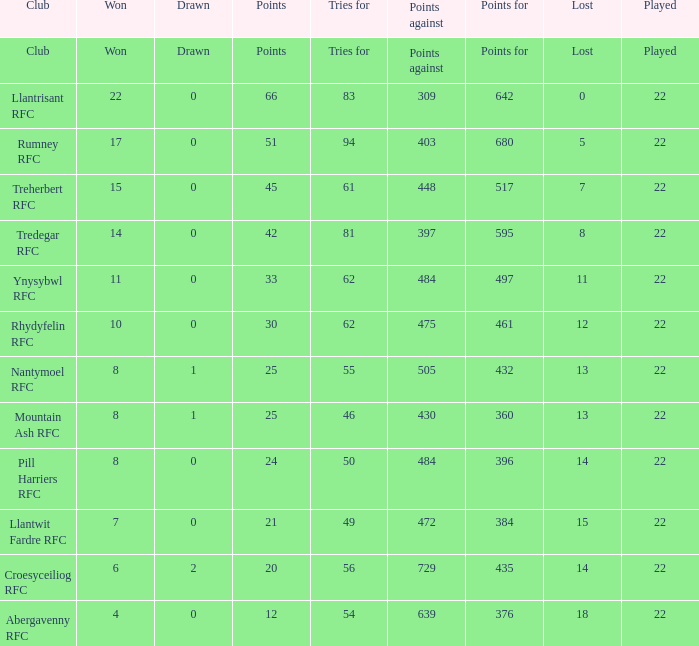Could you parse the entire table as a dict? {'header': ['Club', 'Won', 'Drawn', 'Points', 'Tries for', 'Points against', 'Points for', 'Lost', 'Played'], 'rows': [['Club', 'Won', 'Drawn', 'Points', 'Tries for', 'Points against', 'Points for', 'Lost', 'Played'], ['Llantrisant RFC', '22', '0', '66', '83', '309', '642', '0', '22'], ['Rumney RFC', '17', '0', '51', '94', '403', '680', '5', '22'], ['Treherbert RFC', '15', '0', '45', '61', '448', '517', '7', '22'], ['Tredegar RFC', '14', '0', '42', '81', '397', '595', '8', '22'], ['Ynysybwl RFC', '11', '0', '33', '62', '484', '497', '11', '22'], ['Rhydyfelin RFC', '10', '0', '30', '62', '475', '461', '12', '22'], ['Nantymoel RFC', '8', '1', '25', '55', '505', '432', '13', '22'], ['Mountain Ash RFC', '8', '1', '25', '46', '430', '360', '13', '22'], ['Pill Harriers RFC', '8', '0', '24', '50', '484', '396', '14', '22'], ['Llantwit Fardre RFC', '7', '0', '21', '49', '472', '384', '15', '22'], ['Croesyceiliog RFC', '6', '2', '20', '56', '729', '435', '14', '22'], ['Abergavenny RFC', '4', '0', '12', '54', '639', '376', '18', '22']]} How many matches were drawn by the teams that won exactly 10? 1.0. 